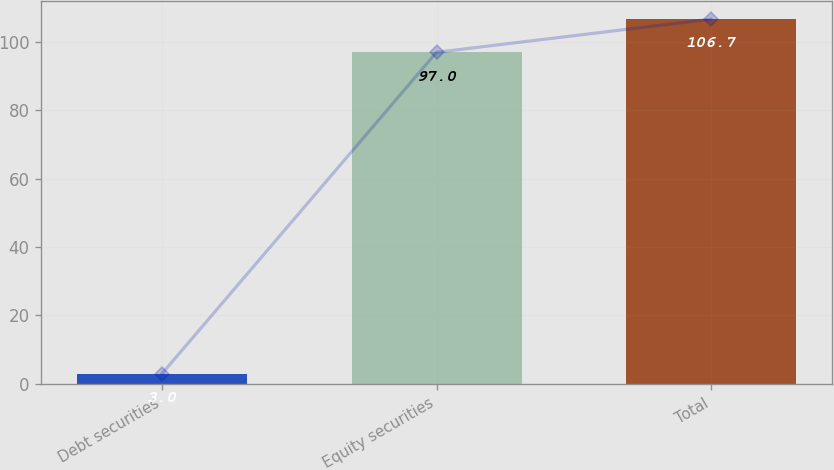Convert chart to OTSL. <chart><loc_0><loc_0><loc_500><loc_500><bar_chart><fcel>Debt securities<fcel>Equity securities<fcel>Total<nl><fcel>3<fcel>97<fcel>106.7<nl></chart> 